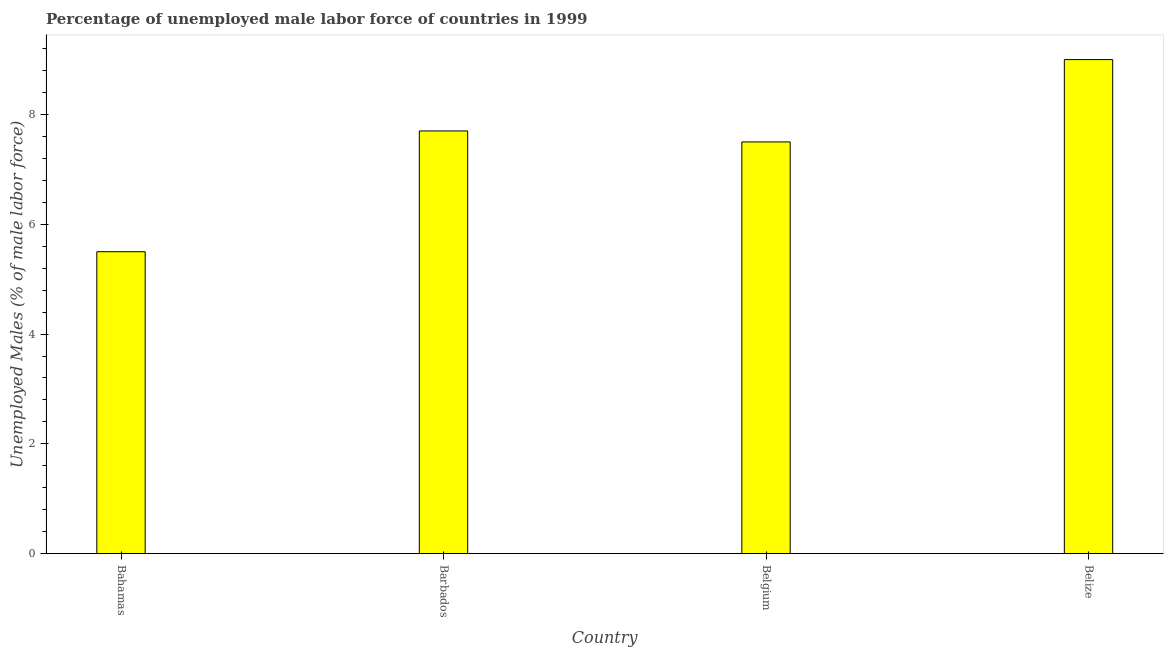Does the graph contain any zero values?
Keep it short and to the point. No. What is the title of the graph?
Make the answer very short. Percentage of unemployed male labor force of countries in 1999. What is the label or title of the X-axis?
Offer a very short reply. Country. What is the label or title of the Y-axis?
Your response must be concise. Unemployed Males (% of male labor force). What is the total unemployed male labour force in Barbados?
Provide a short and direct response. 7.7. In which country was the total unemployed male labour force maximum?
Make the answer very short. Belize. In which country was the total unemployed male labour force minimum?
Provide a succinct answer. Bahamas. What is the sum of the total unemployed male labour force?
Provide a short and direct response. 29.7. What is the difference between the total unemployed male labour force in Belgium and Belize?
Offer a terse response. -1.5. What is the average total unemployed male labour force per country?
Your answer should be compact. 7.42. What is the median total unemployed male labour force?
Make the answer very short. 7.6. What is the ratio of the total unemployed male labour force in Belgium to that in Belize?
Your response must be concise. 0.83. Is the total unemployed male labour force in Bahamas less than that in Belgium?
Ensure brevity in your answer.  Yes. Is the difference between the total unemployed male labour force in Barbados and Belize greater than the difference between any two countries?
Provide a succinct answer. No. What is the difference between the highest and the second highest total unemployed male labour force?
Your answer should be compact. 1.3. How many bars are there?
Provide a short and direct response. 4. Are all the bars in the graph horizontal?
Offer a very short reply. No. What is the Unemployed Males (% of male labor force) of Bahamas?
Ensure brevity in your answer.  5.5. What is the Unemployed Males (% of male labor force) in Barbados?
Offer a very short reply. 7.7. What is the Unemployed Males (% of male labor force) of Belgium?
Give a very brief answer. 7.5. What is the Unemployed Males (% of male labor force) of Belize?
Offer a terse response. 9. What is the difference between the Unemployed Males (% of male labor force) in Belgium and Belize?
Offer a terse response. -1.5. What is the ratio of the Unemployed Males (% of male labor force) in Bahamas to that in Barbados?
Offer a terse response. 0.71. What is the ratio of the Unemployed Males (% of male labor force) in Bahamas to that in Belgium?
Your answer should be compact. 0.73. What is the ratio of the Unemployed Males (% of male labor force) in Bahamas to that in Belize?
Your response must be concise. 0.61. What is the ratio of the Unemployed Males (% of male labor force) in Barbados to that in Belgium?
Your answer should be very brief. 1.03. What is the ratio of the Unemployed Males (% of male labor force) in Barbados to that in Belize?
Keep it short and to the point. 0.86. What is the ratio of the Unemployed Males (% of male labor force) in Belgium to that in Belize?
Keep it short and to the point. 0.83. 